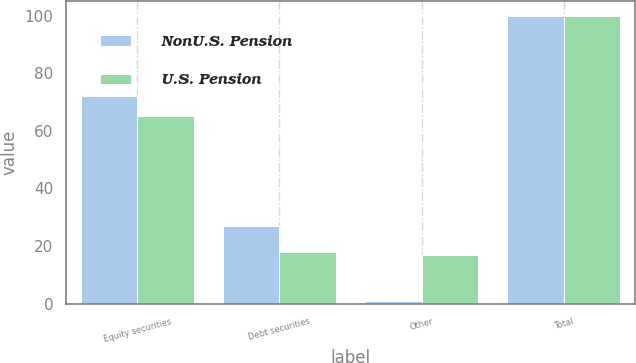<chart> <loc_0><loc_0><loc_500><loc_500><stacked_bar_chart><ecel><fcel>Equity securities<fcel>Debt securities<fcel>Other<fcel>Total<nl><fcel>NonU.S. Pension<fcel>72<fcel>27<fcel>1<fcel>100<nl><fcel>U.S. Pension<fcel>65<fcel>18<fcel>17<fcel>100<nl></chart> 